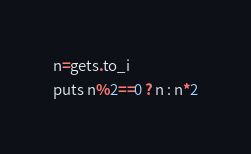Convert code to text. <code><loc_0><loc_0><loc_500><loc_500><_Ruby_>n=gets.to_i
puts n%2==0 ? n : n*2</code> 